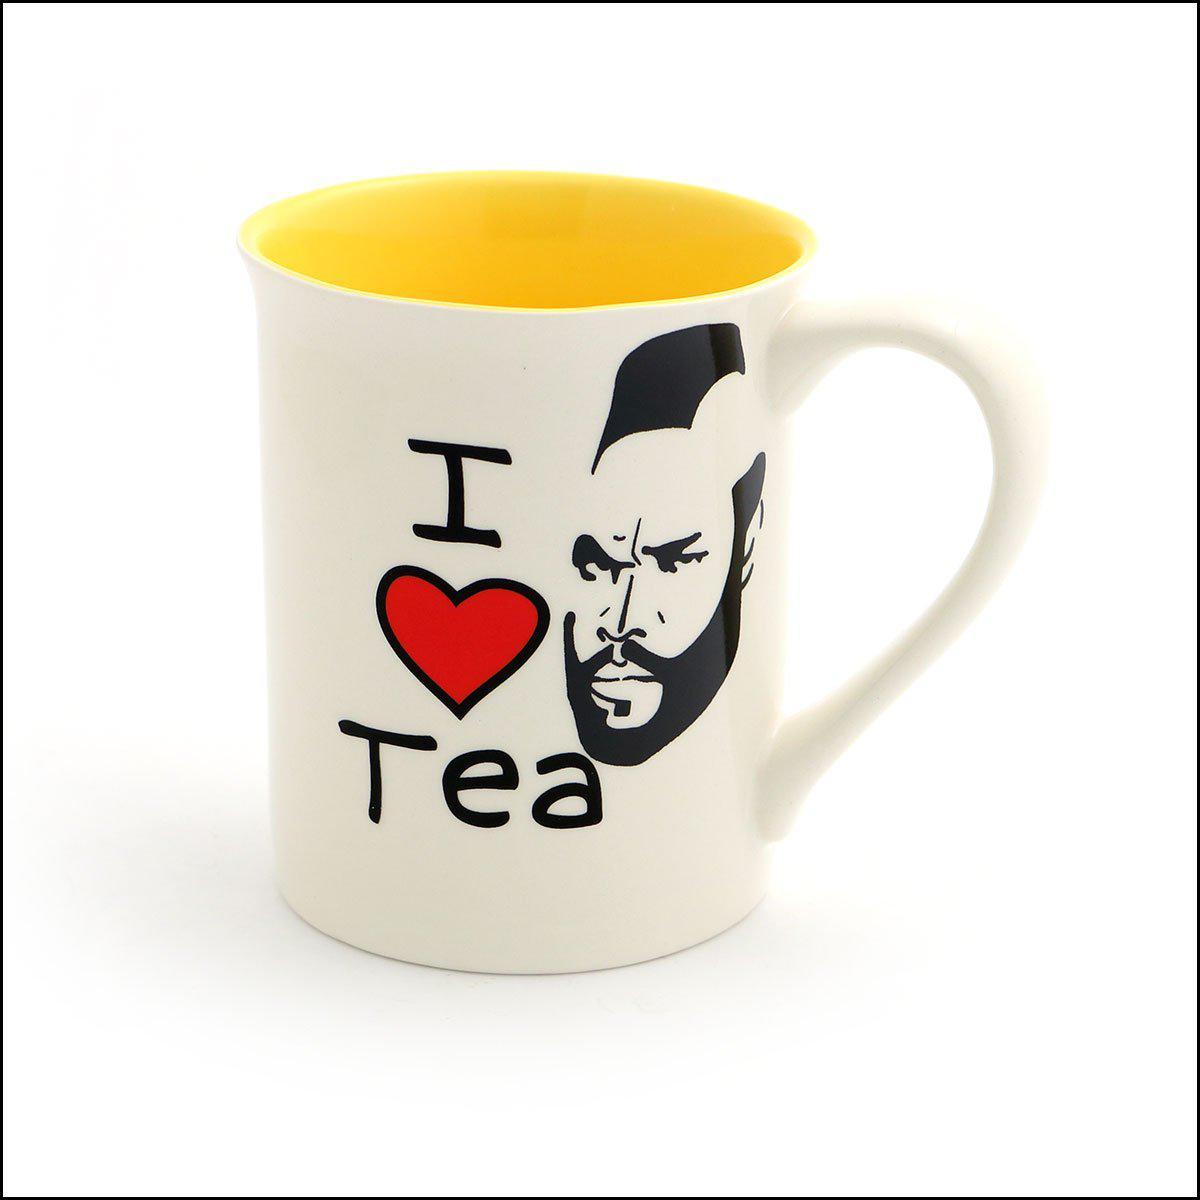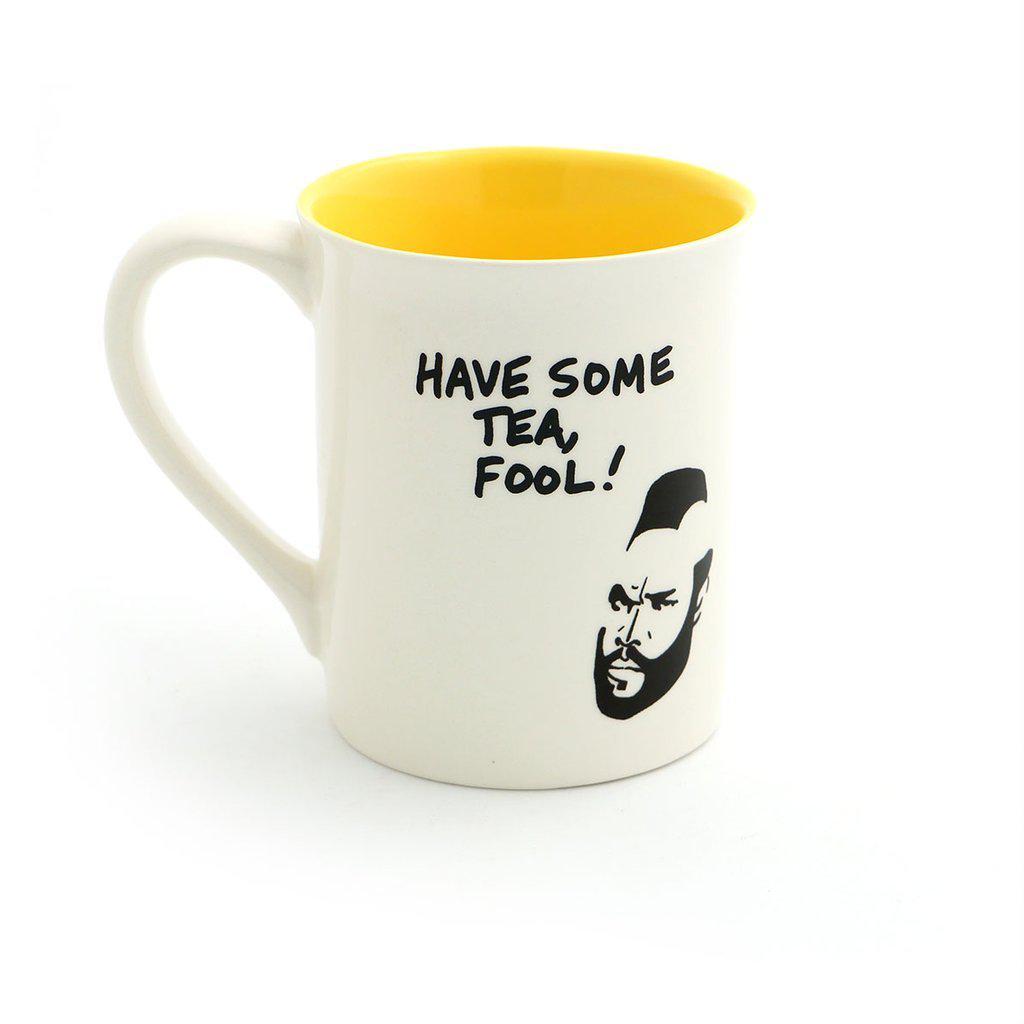The first image is the image on the left, the second image is the image on the right. For the images displayed, is the sentence "One cup is in each image, each decorated with the same person's head, but the cup handles are in opposite directions." factually correct? Answer yes or no. Yes. The first image is the image on the left, the second image is the image on the right. For the images displayed, is the sentence "The combined images contain exactly two mugs, with handles facing opposite directions and a face on each mug." factually correct? Answer yes or no. Yes. 